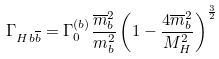Convert formula to latex. <formula><loc_0><loc_0><loc_500><loc_500>\Gamma _ { H b \overline { b } } = \Gamma _ { 0 } ^ { ( b ) } \frac { \overline { m } _ { b } ^ { 2 } } { m _ { b } ^ { 2 } } \left ( 1 - \frac { 4 \overline { m } _ { b } ^ { 2 } } { M _ { H } ^ { 2 } } \right ) ^ { \frac { 3 } { 2 } }</formula> 